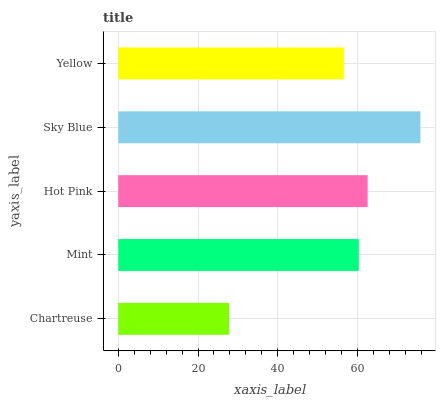Is Chartreuse the minimum?
Answer yes or no. Yes. Is Sky Blue the maximum?
Answer yes or no. Yes. Is Mint the minimum?
Answer yes or no. No. Is Mint the maximum?
Answer yes or no. No. Is Mint greater than Chartreuse?
Answer yes or no. Yes. Is Chartreuse less than Mint?
Answer yes or no. Yes. Is Chartreuse greater than Mint?
Answer yes or no. No. Is Mint less than Chartreuse?
Answer yes or no. No. Is Mint the high median?
Answer yes or no. Yes. Is Mint the low median?
Answer yes or no. Yes. Is Chartreuse the high median?
Answer yes or no. No. Is Yellow the low median?
Answer yes or no. No. 